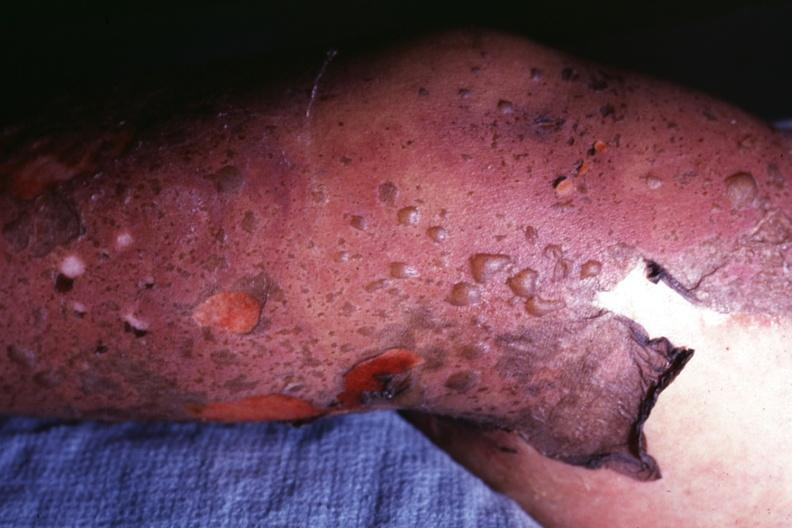what is this?
Answer the question using a single word or phrase. Correct diagnosis as i do not have protocol 